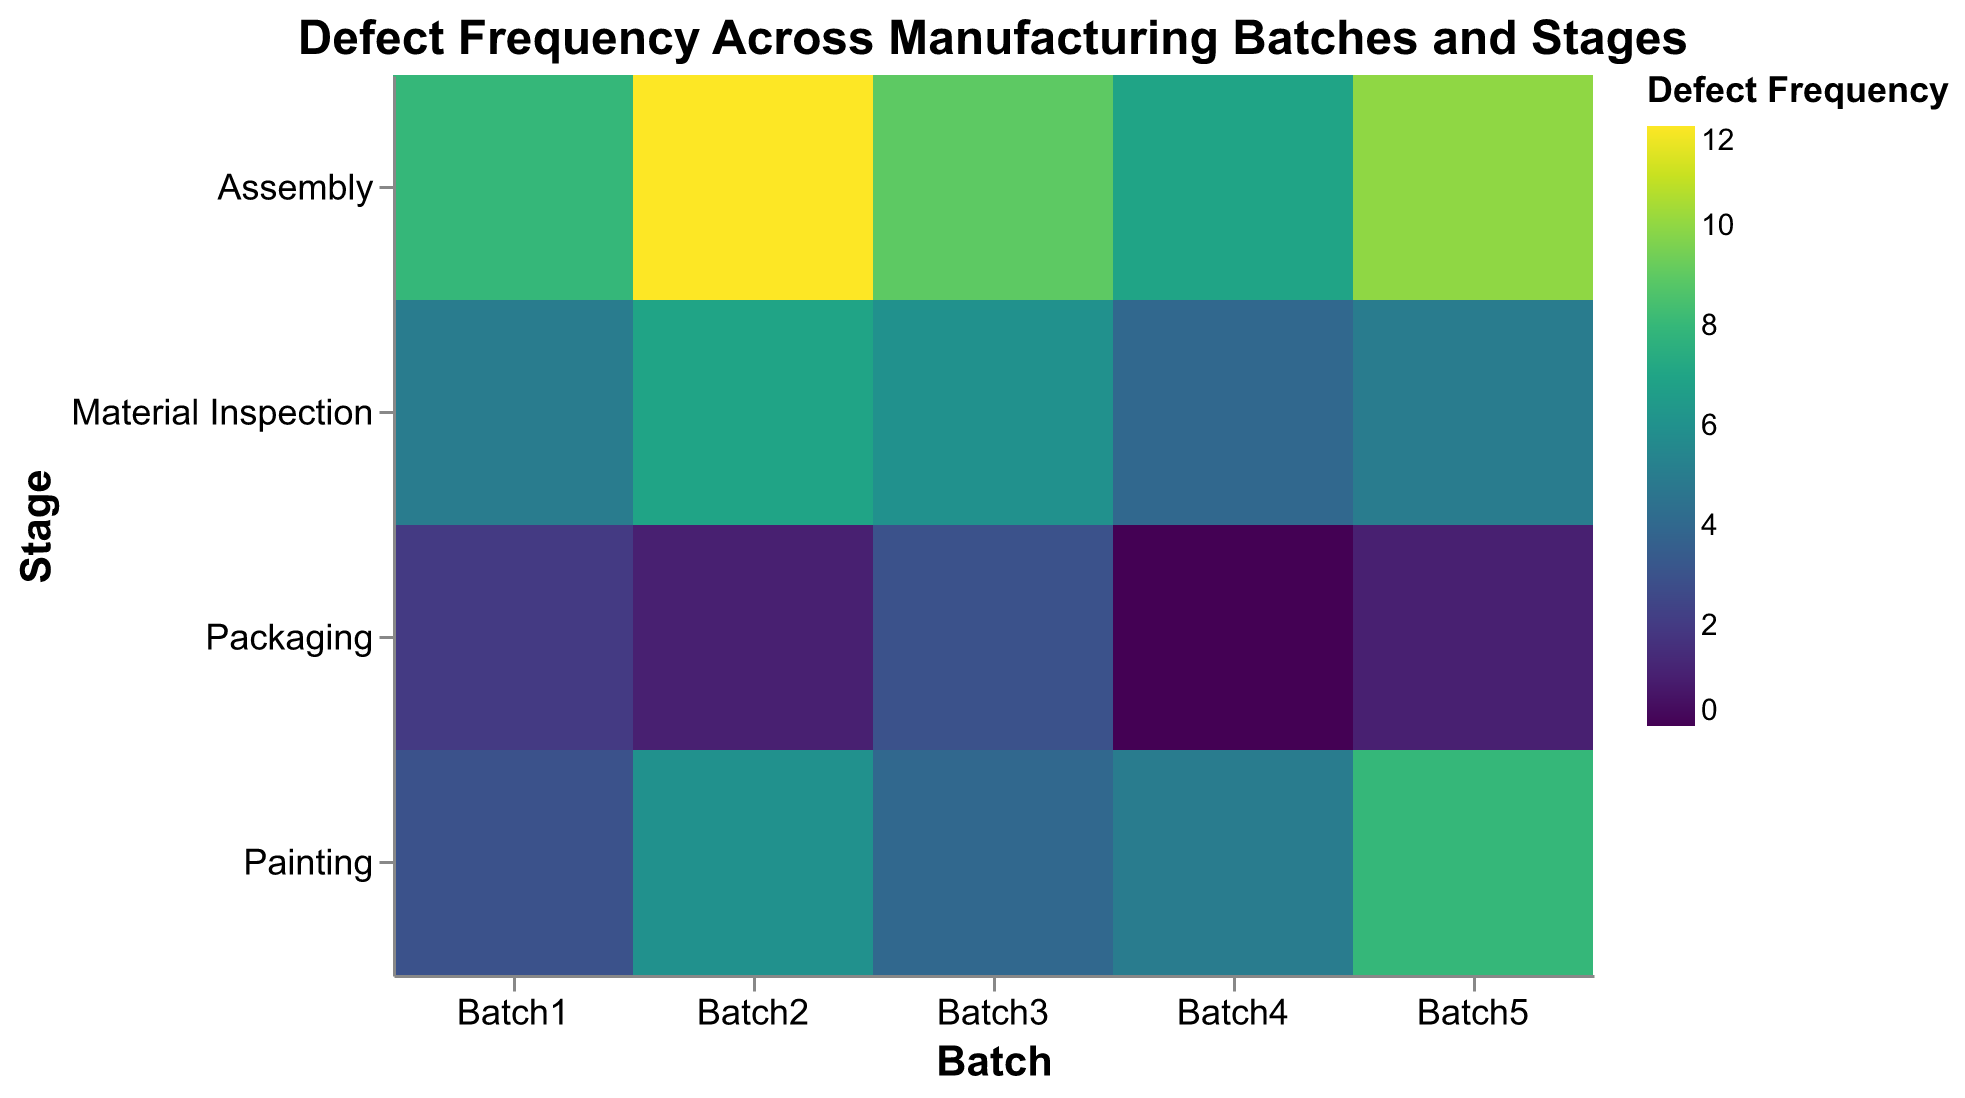What's the title of the figure? The title is located at the top of the figure and describes what the heatmap represents. In this case, it reads "Defect Frequency Across Manufacturing Batches and Stages."
Answer: Defect Frequency Across Manufacturing Batches and Stages Which batch and stage combination has the highest defect frequency? Look for the cell with the darkest color, which indicates the highest defect frequency. The batch and stage with the highest value is Batch2 in the Assembly stage.
Answer: Batch2, Assembly What is the defect frequency in the Painting stage for Batch4? Find the intersection of Batch4 and the Painting stage, which will have a specific color shaded according to the defect frequency legend. The color indicates that the defect frequency at this point is 5.
Answer: 5 Which stage has the lowest overall defect frequency across all batches? To determine this, look for the stage which has the lightest color cells predominantly across all batches. The Packaging stage has consistently low defect frequencies shown by the lighter shades.
Answer: Packaging What's the average defect frequency in the Assembly stage across all batches? Calculate the average by adding up the defect frequencies in the Assembly stage for all batches and then dividing by the number of batches. The values are 8, 12, 9, 7, and 10. The sum is 46, and the average is 46/5 = 9.2.
Answer: 9.2 Which batch has the most consistent defect frequency across all stages? Evaluate each batch to see the variance in defect frequencies across all stages. Batch4 has the most consistent defect frequencies with values close to each other: 4, 7, 5, 0.
Answer: Batch4 How do defect frequencies compare between the Material Inspection and Packaging stages? Compare the defect frequencies at these two stages across all batches. Material Inspection has consistently higher defect frequencies compared to Packaging, which has generally the lowest frequencies.
Answer: Material Inspection > Packaging What pattern do you observe in defect frequencies for Batch3 across different stages? Looking across Batch3 rows, the defect frequency starts higher at Material Inspection (6), increases to Assembly (9), drops at Painting (4), and slightly increases again at Packaging (3).
Answer: High in Assembly, moderate in Material Inspection and Painting, low in Packaging In which batches do the Painting and Assembly stages show significant differences in defect frequencies? Compare the defect frequencies in the Painting and Assembly stages for each batch. Batch1 (3 vs 8), Batch2 (6 vs 12), and Batch5 (8 vs 10) show significant differences.
Answer: Batch1, Batch2, Batch5 If Batch1’s Packaging stage defect frequency were to rise by 2, how would it affect its rank among other batches’ Packaging stage frequencies? To answer, increase Batch1's Packaging stage defect frequency from 2 to 4 and rank it. The new value 4 will make it the second highest among Packaging frequencies, after Batch3 and Batch5 with 3 each.
Answer: Second highest 